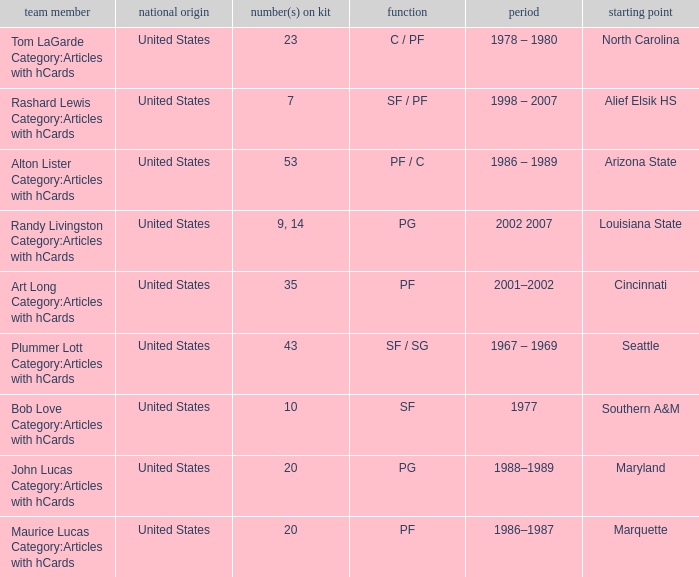What years are recorded in the alton lister category: articles with hcards? 1986 – 1989. 